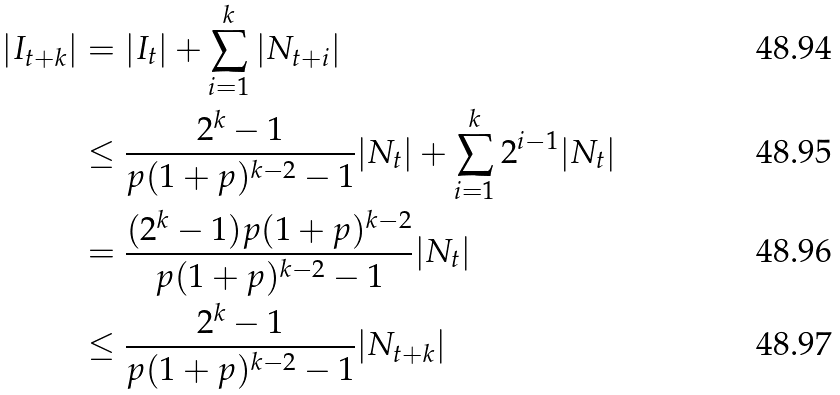Convert formula to latex. <formula><loc_0><loc_0><loc_500><loc_500>| I _ { t + k } | & = | I _ { t } | + \sum _ { i = 1 } ^ { k } | N _ { t + i } | \\ & \leq \frac { 2 ^ { k } - 1 } { p ( 1 + p ) ^ { k - 2 } - 1 } | N _ { t } | + \sum _ { i = 1 } ^ { k } 2 ^ { i - 1 } | N _ { t } | \\ & = \frac { ( 2 ^ { k } - 1 ) p ( 1 + p ) ^ { k - 2 } } { p ( 1 + p ) ^ { k - 2 } - 1 } | N _ { t } | \\ & \leq \frac { 2 ^ { k } - 1 } { p ( 1 + p ) ^ { k - 2 } - 1 } | N _ { t + k } |</formula> 